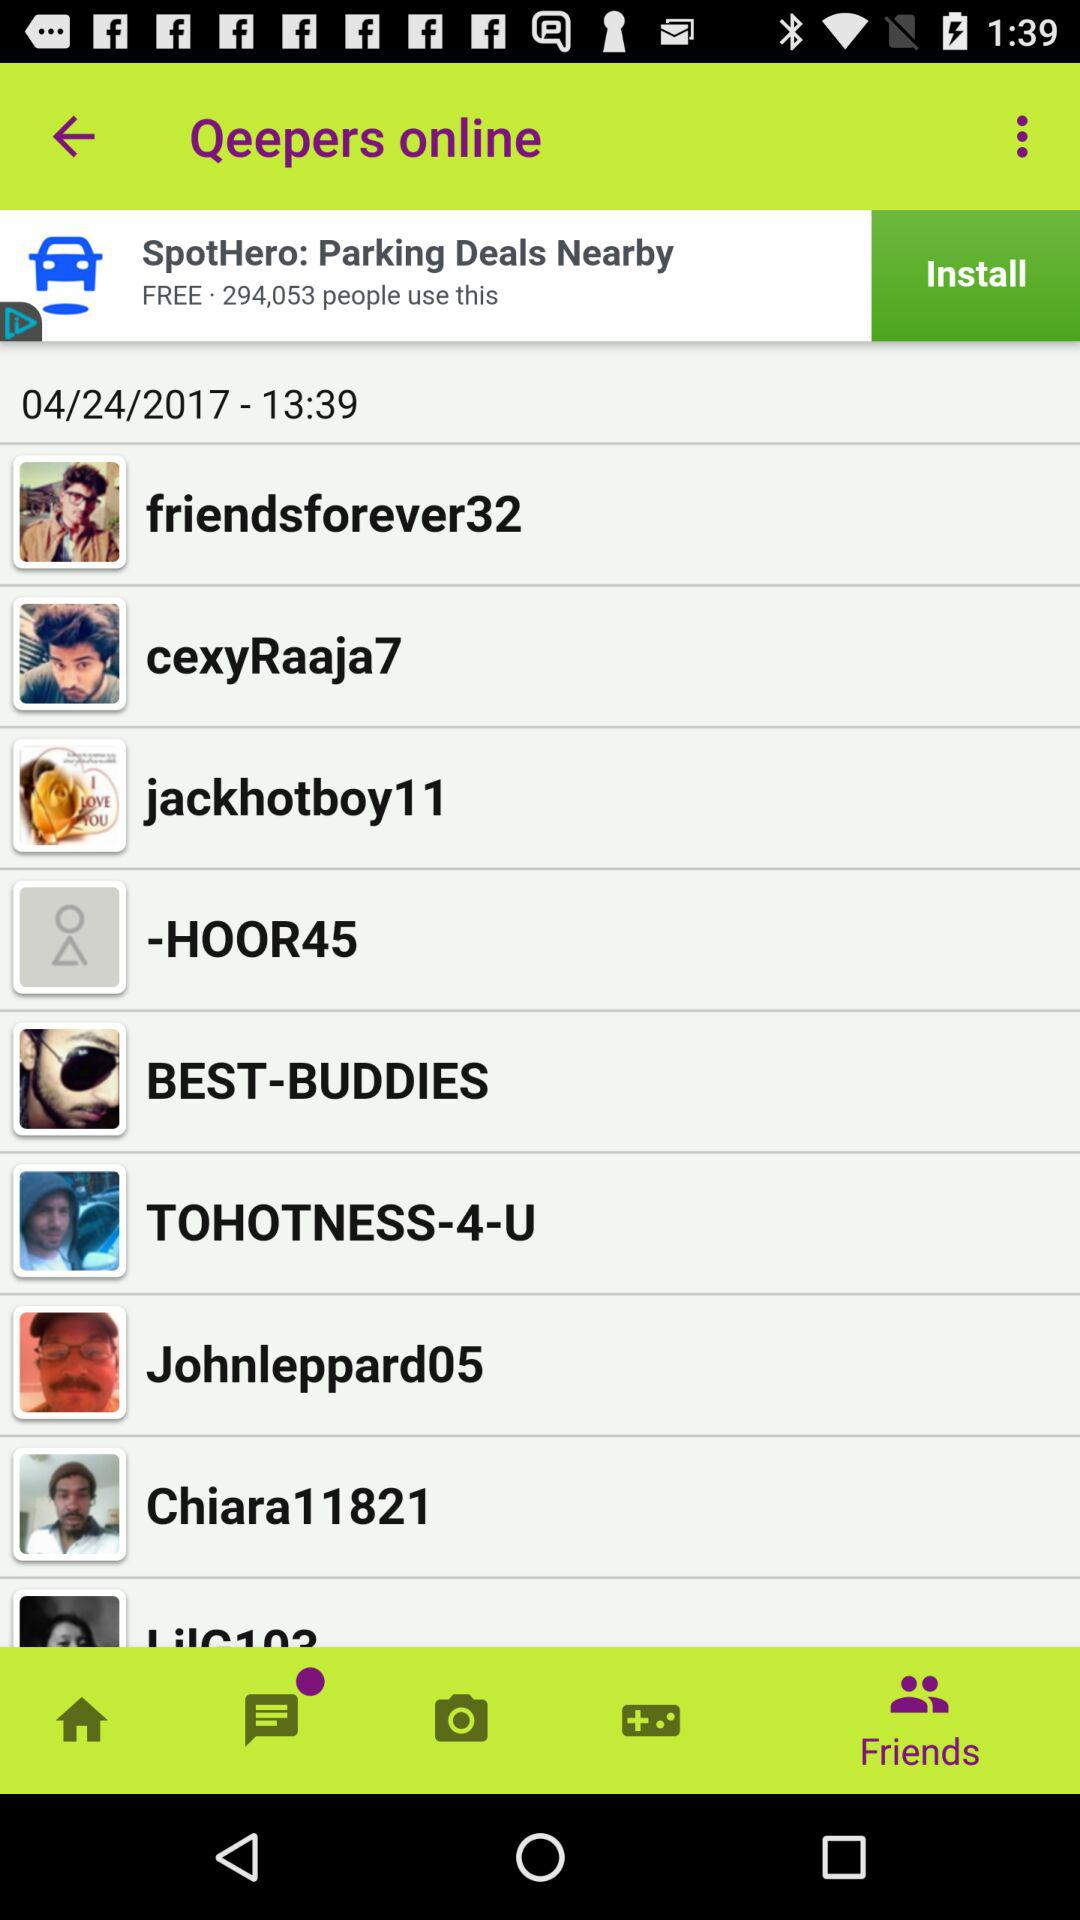What is the selected tab? The selected tab is "Friends". 